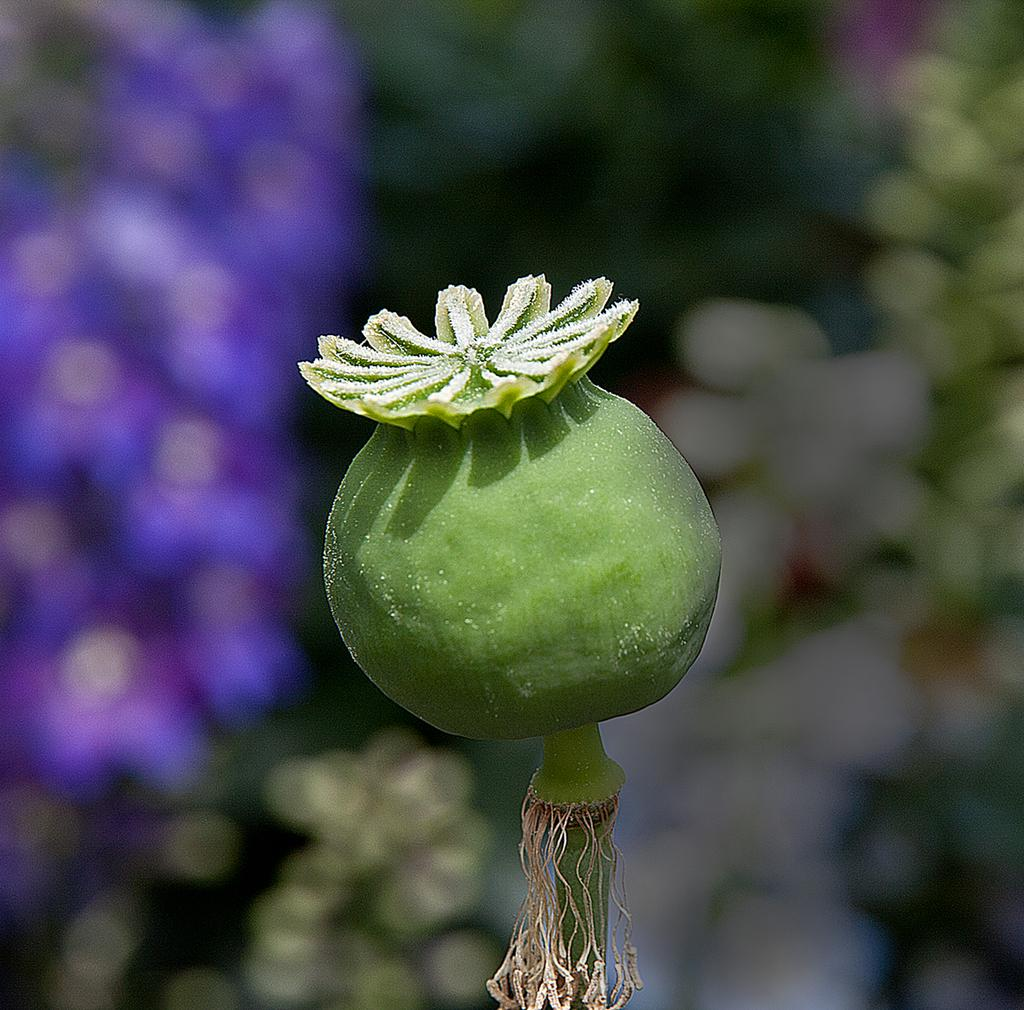What type of food is present in the image? There is fruit in the image. What color is the fruit? The fruit is green in color. Can you describe any other features of the fruit? The fruit has roots. What company is responsible for producing the pigs in the image? There are no pigs present in the image, so it is not possible to determine which company might be responsible for producing them. 